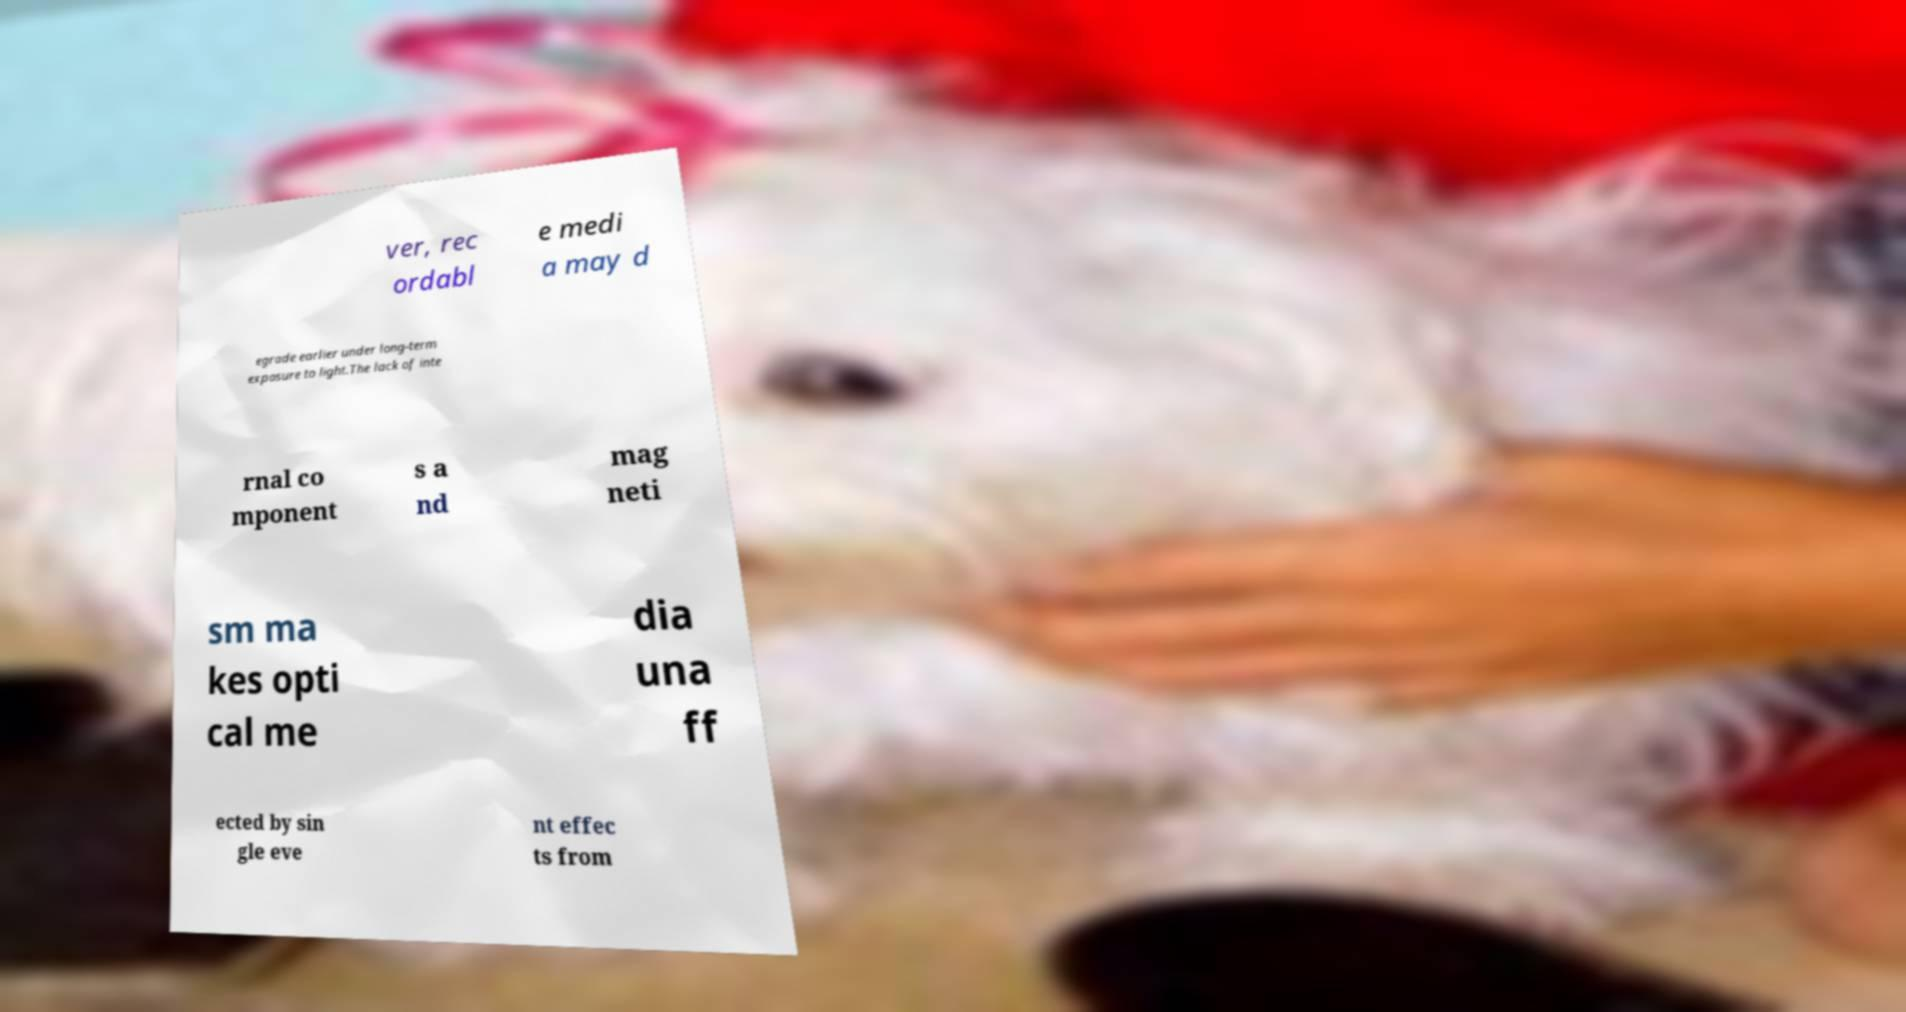Can you read and provide the text displayed in the image?This photo seems to have some interesting text. Can you extract and type it out for me? ver, rec ordabl e medi a may d egrade earlier under long-term exposure to light.The lack of inte rnal co mponent s a nd mag neti sm ma kes opti cal me dia una ff ected by sin gle eve nt effec ts from 